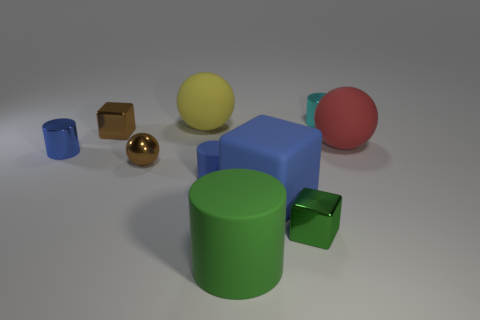Are there fewer green matte objects that are to the right of the big green matte cylinder than matte things that are left of the large cube?
Make the answer very short. Yes. How many other things are made of the same material as the tiny green cube?
Make the answer very short. 4. Are the big blue cube and the red ball made of the same material?
Give a very brief answer. Yes. How many other objects are there of the same size as the blue matte cylinder?
Make the answer very short. 5. There is a metallic cube that is on the left side of the rubber object that is in front of the large blue rubber cube; how big is it?
Your response must be concise. Small. There is a shiny cylinder in front of the tiny metallic cylinder that is behind the large rubber object that is to the left of the big matte cylinder; what color is it?
Offer a terse response. Blue. How big is the metal thing that is to the right of the big yellow object and in front of the cyan shiny thing?
Your answer should be very brief. Small. What number of other objects are there of the same shape as the yellow rubber object?
Make the answer very short. 2. How many balls are either yellow metal objects or green objects?
Your answer should be very brief. 0. Are there any red balls that are in front of the block that is behind the small metal cylinder that is in front of the cyan cylinder?
Give a very brief answer. Yes. 